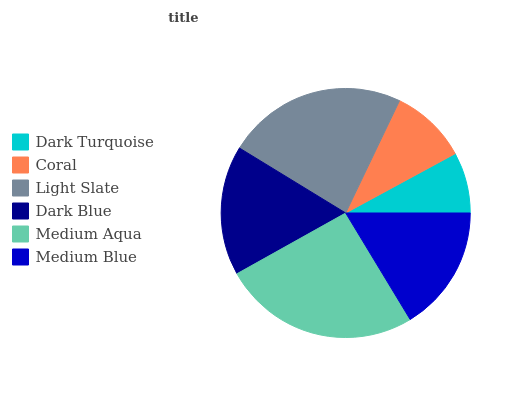Is Dark Turquoise the minimum?
Answer yes or no. Yes. Is Medium Aqua the maximum?
Answer yes or no. Yes. Is Coral the minimum?
Answer yes or no. No. Is Coral the maximum?
Answer yes or no. No. Is Coral greater than Dark Turquoise?
Answer yes or no. Yes. Is Dark Turquoise less than Coral?
Answer yes or no. Yes. Is Dark Turquoise greater than Coral?
Answer yes or no. No. Is Coral less than Dark Turquoise?
Answer yes or no. No. Is Dark Blue the high median?
Answer yes or no. Yes. Is Medium Blue the low median?
Answer yes or no. Yes. Is Medium Blue the high median?
Answer yes or no. No. Is Medium Aqua the low median?
Answer yes or no. No. 